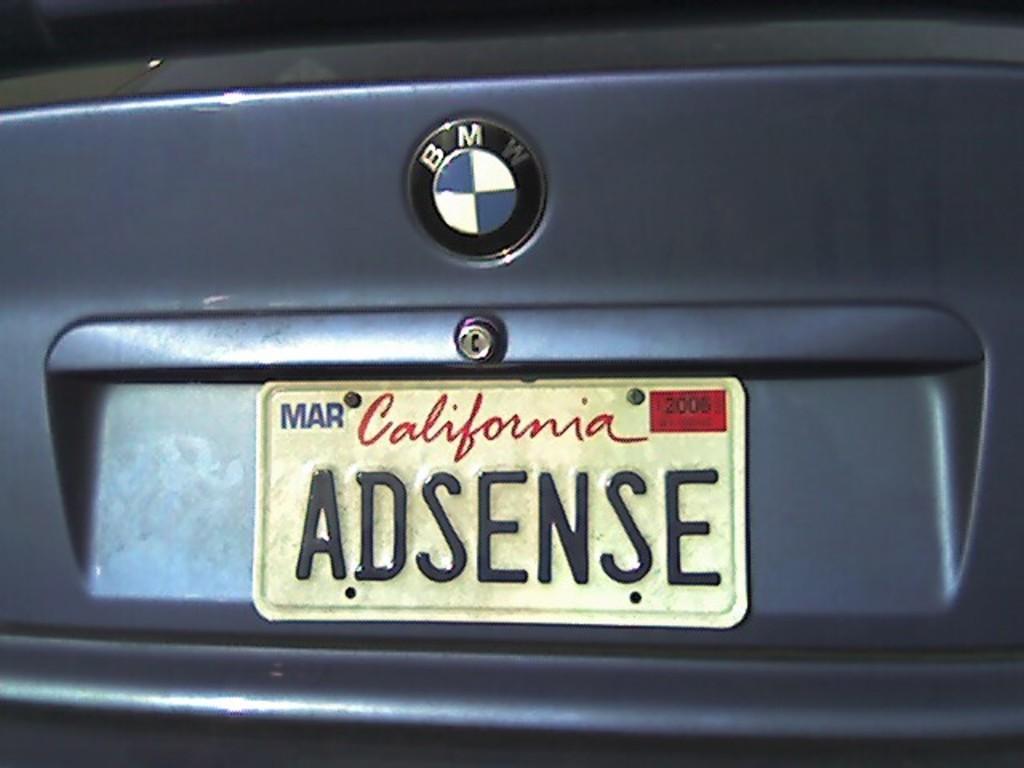What is the license plate number?
Give a very brief answer. Adsense. 